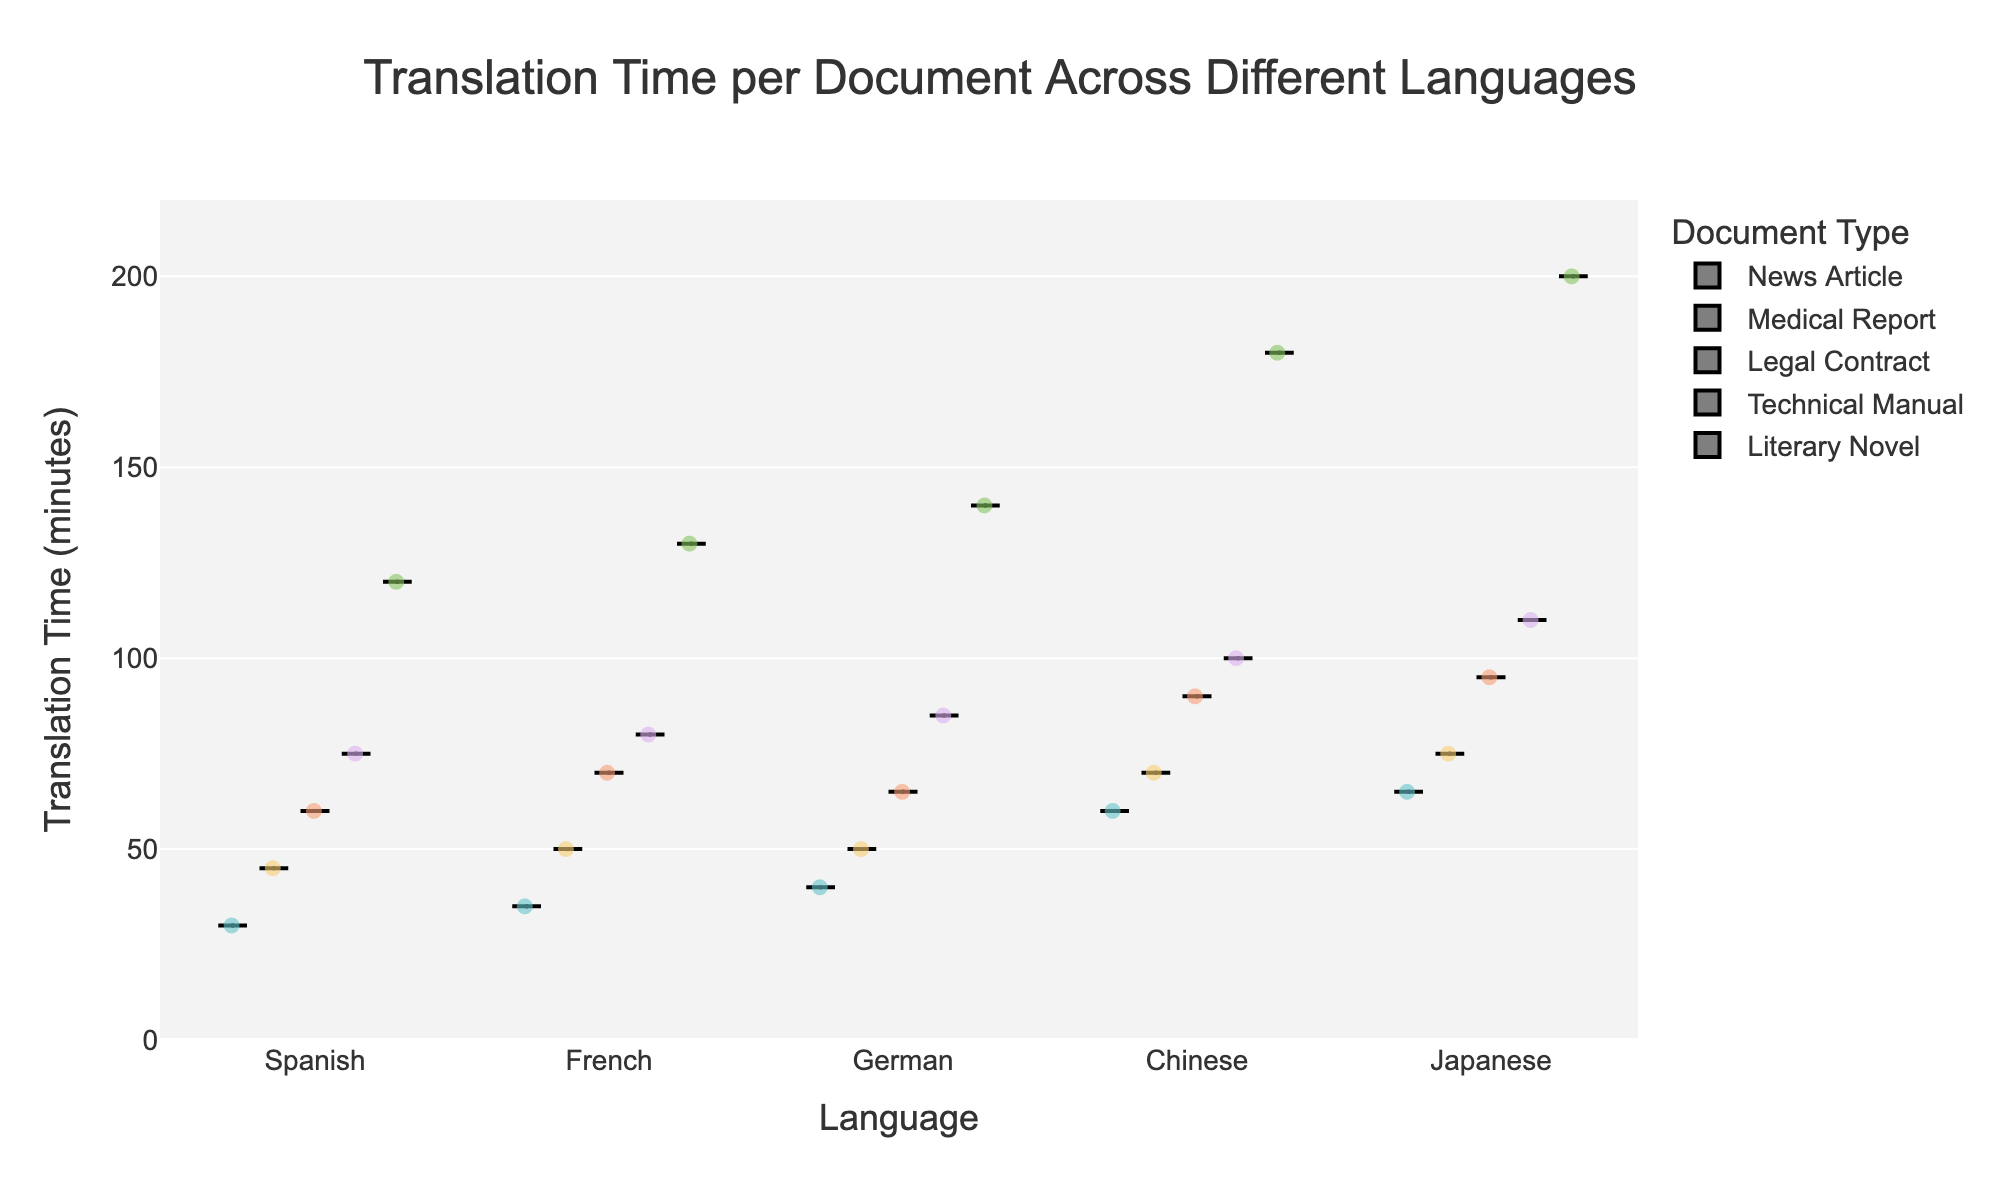What is the title of the figure? The title of the figure is found at the top of the image and summarizes what the figure is depicting. It is usually a brief description of the content of the figure.
Answer: Translation Time per Document Across Different Languages Which document type has the highest translation time in Japanese? To find this, locate Japanese on the x-axis, then check the violin plot for each document type within that category to see which one has the highest point.
Answer: Literary Novel How does the translation time for Medical Reports differ between Chinese and German? Compare the position of the points and the distribution shape for Medical Reports in the Chinese and German violin plots to see how translation times vary.
Answer: Medical Reports in Chinese take more time than in German What is the average translation time for News Articles in Spanish? Look for the box plot within the violin plot for News Articles under Spanish. The average translation time is represented by the middle line of the box.
Answer: 30 minutes Which language shows the widest variation in translation time for Technical Manuals? Identify the language with the largest spread in the violin plot for Technical Manuals by looking at the width and range of the plot.
Answer: Japanese Are Legal Contracts translated faster in French or Japanese? Check the position of the central tendency (like the median or mean line) within the box plots for Legal Contracts in French and Japanese, to determine which has the lower value.
Answer: French What is the median translation time for Literary Novels in German? The median is indicated by the line in the center of the box plot within the German Literary Novel violin plot.
Answer: 140 minutes How many translation time data points are there for News Articles in Chinese? The number of data points is represented by the number of jittered points (dots) within the News Article violin plot under Chinese.
Answer: 1 Which document type generally has the shortest translation time across all languages? Look for the document type with the lowest central tendency (mean line) across all violin plots for different languages.
Answer: News Article 